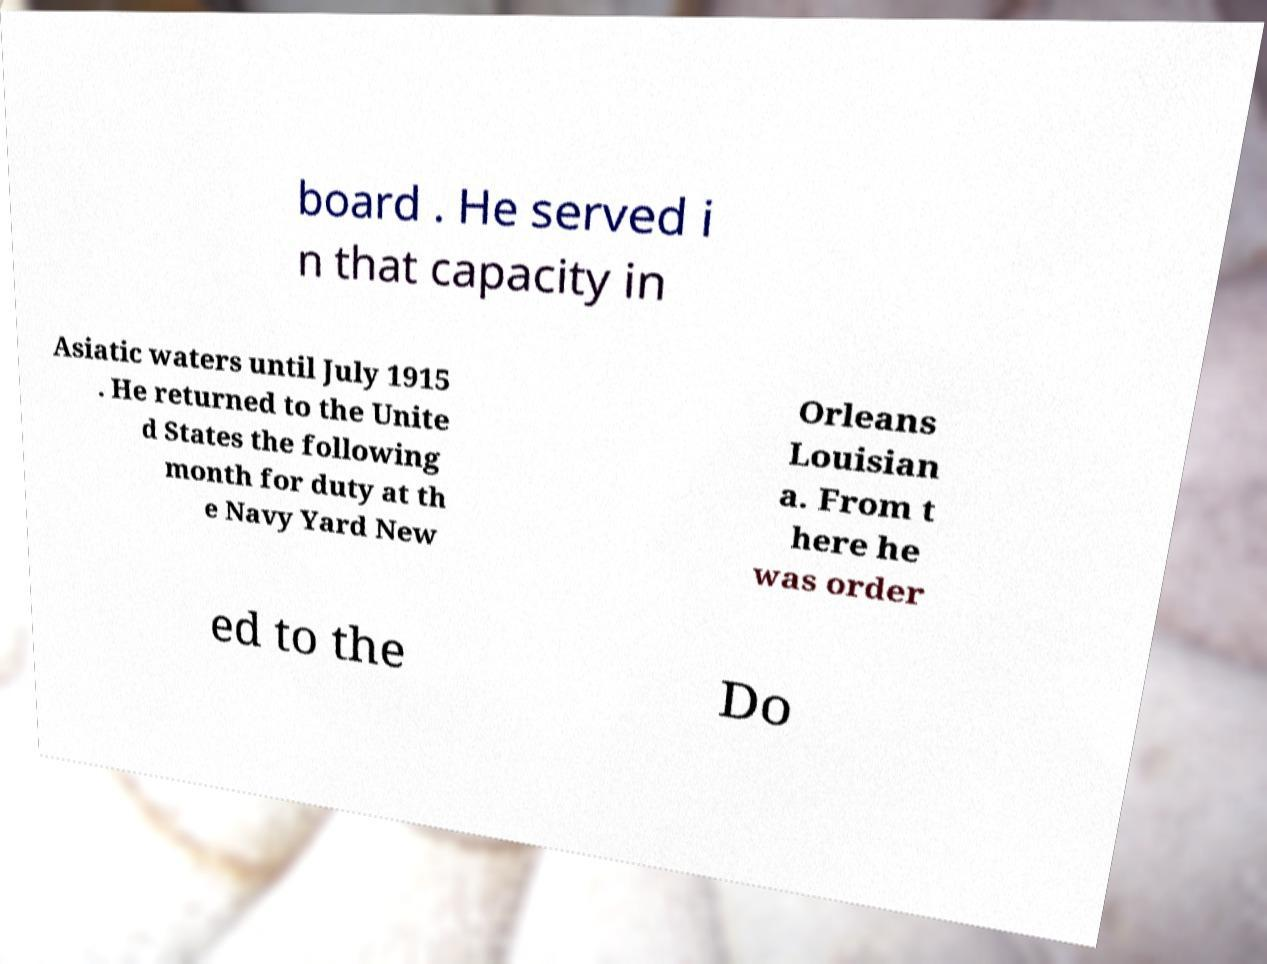There's text embedded in this image that I need extracted. Can you transcribe it verbatim? board . He served i n that capacity in Asiatic waters until July 1915 . He returned to the Unite d States the following month for duty at th e Navy Yard New Orleans Louisian a. From t here he was order ed to the Do 